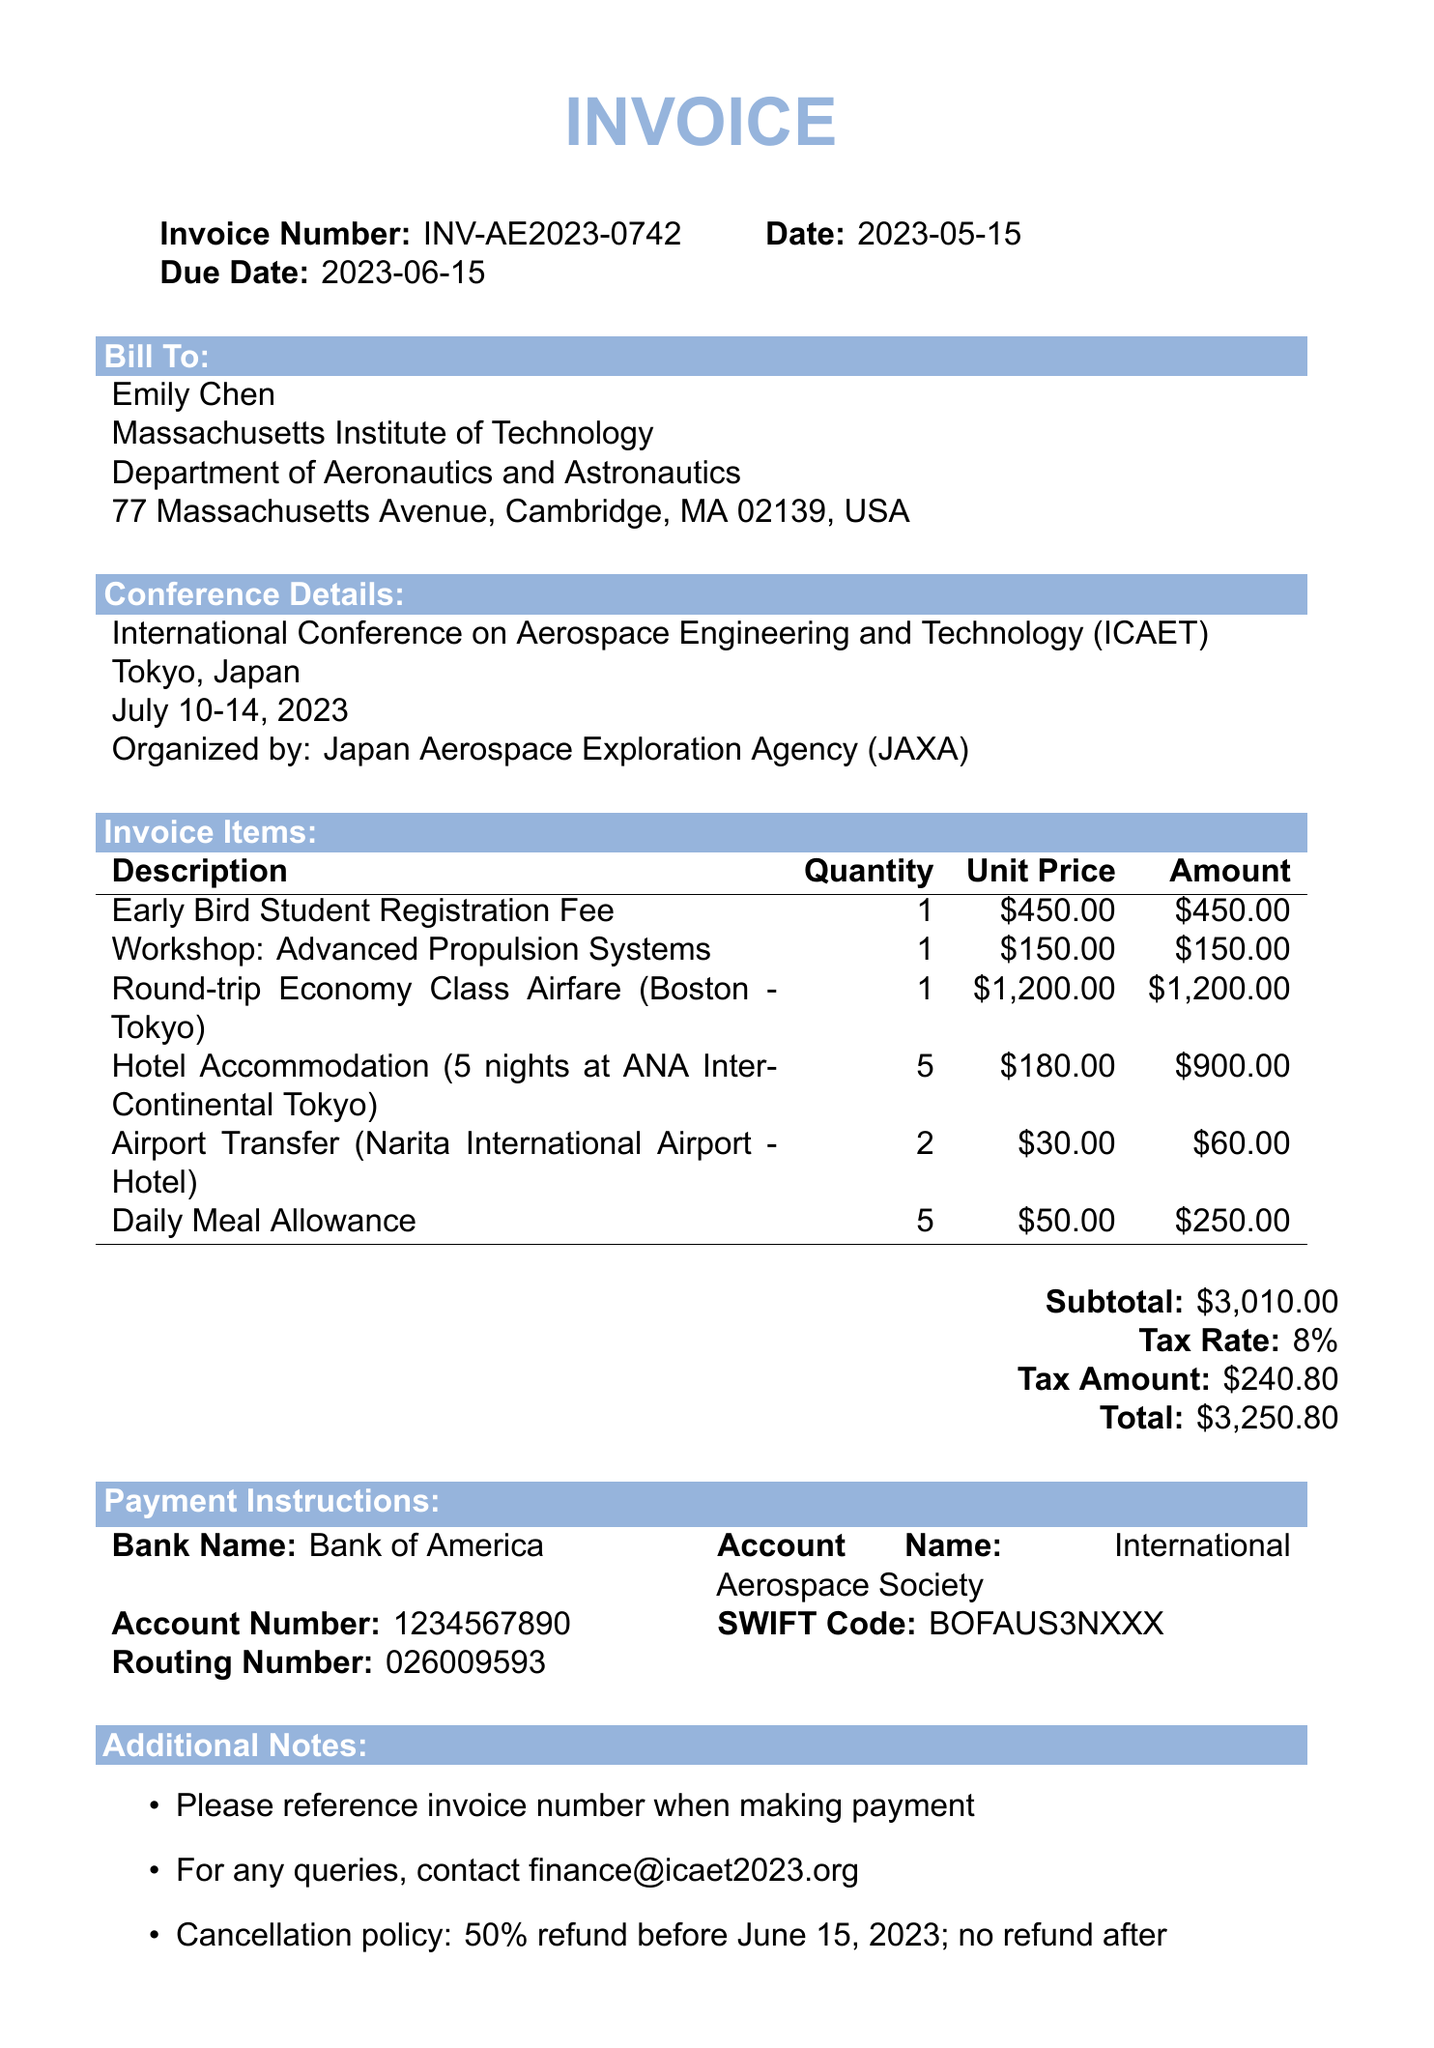What is the invoice number? The invoice number is clearly stated in the document header under invoice details.
Answer: INV-AE2023-0742 Who is the bill to? The billing information includes the name, university, and department of the individual.
Answer: Emily Chen What is the total amount due? The total amount is listed at the end of the invoice, summarizing all costs.
Answer: $3250.80 How many nights of hotel accommodation are included? The invoice details the duration of hotel stay under line items.
Answer: 5 nights What is the due date for payment? The due date is indicated clearly in the invoice header section.
Answer: 2023-06-15 What is the tax rate applied to the subtotal? The tax rate is specified after the subtotal in the invoice.
Answer: 8% What organization is organizing the conference? The organizing body of the conference is mentioned in the conference details section.
Answer: Japan Aerospace Exploration Agency (JAXA) What is the cancellation policy? The cancellation policy is provided in the additional notes section of the invoice.
Answer: 50% refund before June 15, 2023; no refund after What is the unit price for the Daily Meal Allowance? The unit price for meals is listed alongside the quantity and amount in the line items.
Answer: $50.00 